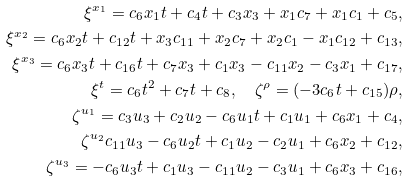Convert formula to latex. <formula><loc_0><loc_0><loc_500><loc_500>\xi ^ { x _ { 1 } } = c _ { 6 } x _ { 1 } t + c _ { 4 } t + c _ { 3 } x _ { 3 } + x _ { 1 } c _ { 7 } + x _ { 1 } c _ { 1 } + c _ { 5 } , \\ \xi ^ { x _ { 2 } } = c _ { 6 } x _ { 2 } t + c _ { 1 2 } t + x _ { 3 } c _ { 1 1 } + x _ { 2 } c _ { 7 } + x _ { 2 } c _ { 1 } - x _ { 1 } c _ { 1 2 } + c _ { 1 3 } , \\ \xi ^ { x _ { 3 } } = c _ { 6 } x _ { 3 } t + c _ { 1 6 } t + c _ { 7 } x _ { 3 } + c _ { 1 } x _ { 3 } - c _ { 1 1 } x _ { 2 } - c _ { 3 } x _ { 1 } + c _ { 1 7 } , \\ \xi ^ { t } = c _ { 6 } t ^ { 2 } + c _ { 7 } t + c _ { 8 } , \quad \zeta ^ { \rho } = ( - 3 c _ { 6 } t + c _ { 1 5 } ) \rho , \\ \zeta ^ { u _ { 1 } } = c _ { 3 } u _ { 3 } + c _ { 2 } u _ { 2 } - c _ { 6 } u _ { 1 } t + c _ { 1 } u _ { 1 } + c _ { 6 } x _ { 1 } + c _ { 4 } , \\ \zeta ^ { u _ { 2 } } c _ { 1 1 } u _ { 3 } - c _ { 6 } u _ { 2 } t + c _ { 1 } u _ { 2 } - c _ { 2 } u _ { 1 } + c _ { 6 } x _ { 2 } + c _ { 1 2 } , \\ \zeta ^ { u _ { 3 } } = - c _ { 6 } u _ { 3 } t + c _ { 1 } u _ { 3 } - c _ { 1 1 } u _ { 2 } - c _ { 3 } u _ { 1 } + c _ { 6 } x _ { 3 } + c _ { 1 6 } ,</formula> 